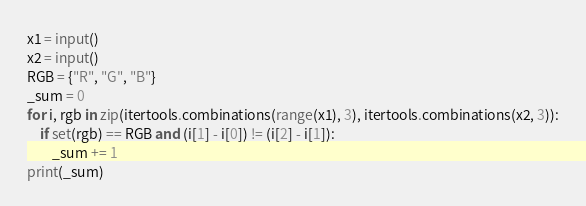Convert code to text. <code><loc_0><loc_0><loc_500><loc_500><_Python_>x1 = input()
x2 = input()
RGB = {"R", "G", "B"}
_sum = 0
for i, rgb in zip(itertools.combinations(range(x1), 3), itertools.combinations(x2, 3)):
    if set(rgb) == RGB and (i[1] - i[0]) != (i[2] - i[1]):
        _sum += 1
print(_sum)</code> 